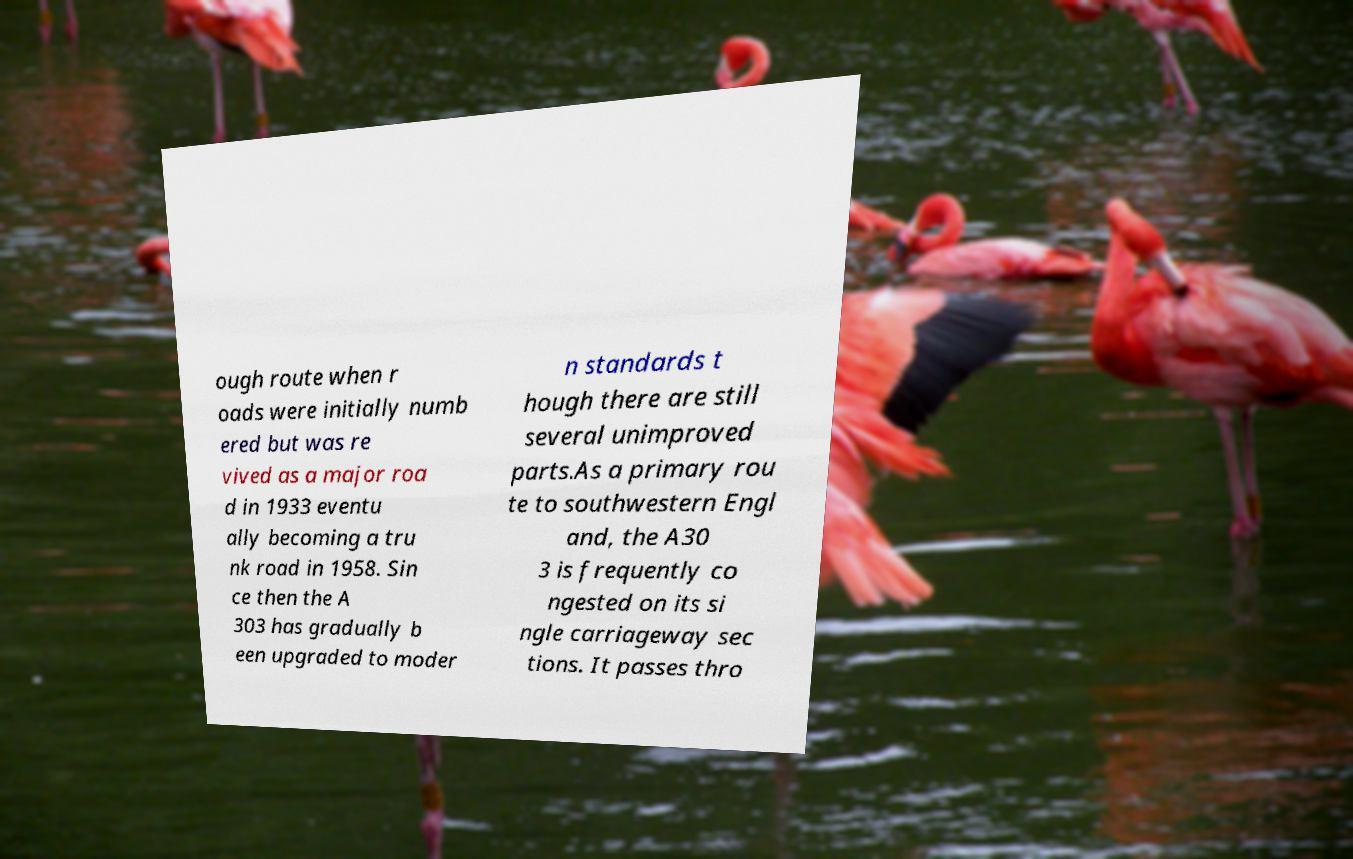There's text embedded in this image that I need extracted. Can you transcribe it verbatim? ough route when r oads were initially numb ered but was re vived as a major roa d in 1933 eventu ally becoming a tru nk road in 1958. Sin ce then the A 303 has gradually b een upgraded to moder n standards t hough there are still several unimproved parts.As a primary rou te to southwestern Engl and, the A30 3 is frequently co ngested on its si ngle carriageway sec tions. It passes thro 